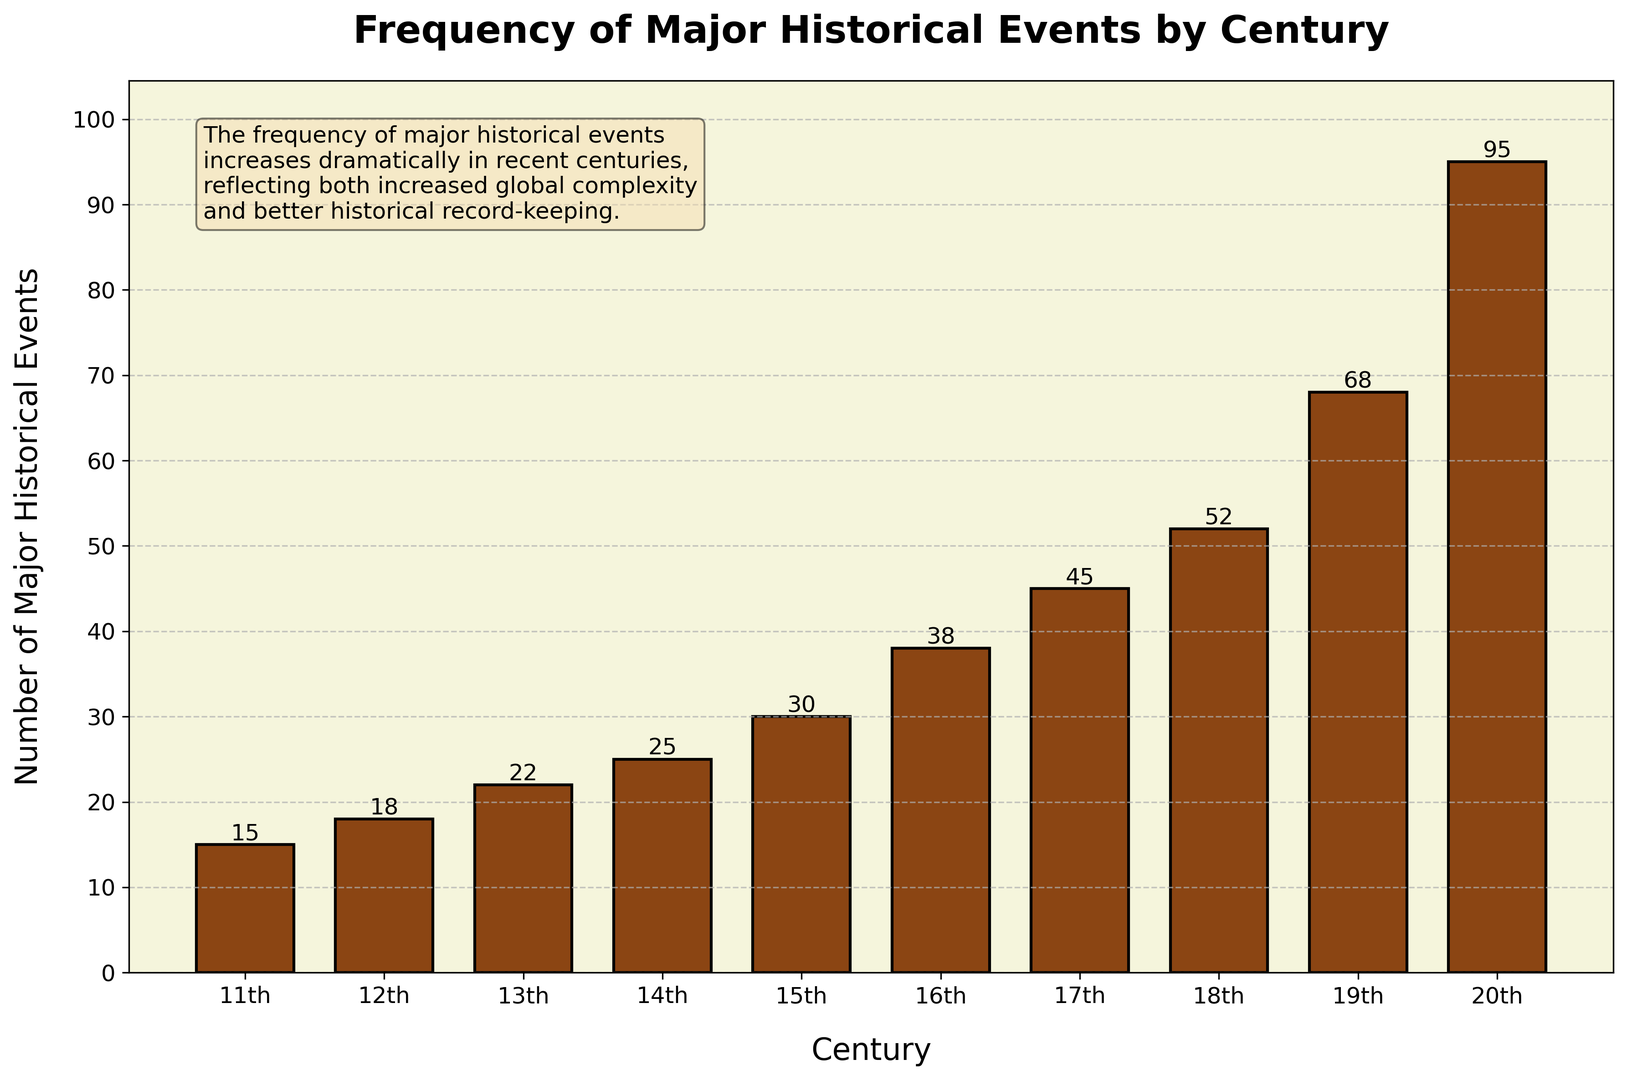What century had the highest number of major historical events? The highest bar in the histogram represents the 20th century with 95 events. This indicates it had the highest number of major historical events.
Answer: 20th century How many more major historical events occurred in the 19th century compared to the 14th century? The 19th century had 68 events and the 14th century had 25 events. Subtracting 25 from 68 gives 43.
Answer: 43 What is the average number of major historical events per century between the 11th and 15th centuries? Sum the events from the 11th to the 15th centuries: 15 + 18 + 22 + 25 + 30 = 110. There are 5 centuries, so the average is 110 / 5 = 22.
Answer: 22 Comparing the 16th and 18th centuries, which century had fewer major historical events and by how many? The 16th century had 38 events while the 18th century had 52 events. Subtracting 38 from 52 gives 14.
Answer: 16th century by 14 events What is the median number of major historical events from the 11th to the 20th centuries? List the numbers: 15, 18, 22, 25, 30, 38, 45, 52, 68, 95. The median is the average of the 5th and 6th values (30 and 38), which is (30 + 38) / 2 = 34.
Answer: 34 Does the trend show an increase or decrease in the frequency of major historical events over the centuries? The histogram shows that the number of major historical events generally increases from the 11th to the 20th centuries.
Answer: Increase Which century marks the first appearance of more than 50 major historical events? The 18th century is the first to have more than 50 events, specifically 52.
Answer: 18th century How many total major historical events are recorded from the 11th to the 20th centuries? Sum all the events: 15 + 18 + 22 + 25 + 30 + 38 + 45 + 52 + 68 + 95 = 408.
Answer: 408 Which centuries have less than 20 major historical events? The 11th and 12th centuries have 15 and 18 events, respectively, both less than 20.
Answer: 11th and 12th centuries 